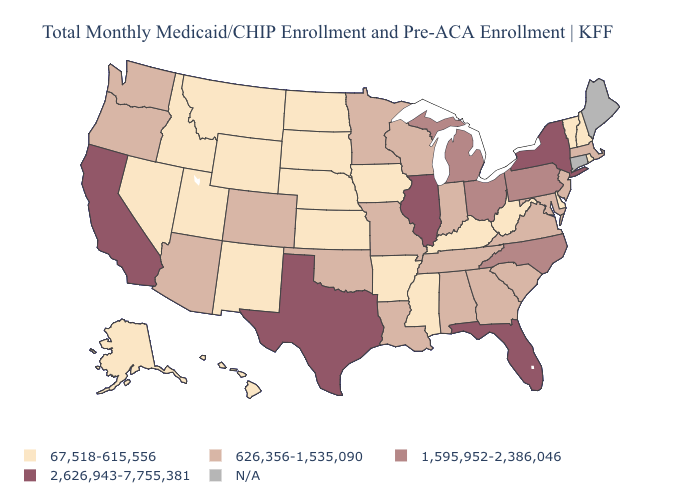Does the first symbol in the legend represent the smallest category?
Be succinct. Yes. What is the lowest value in the West?
Short answer required. 67,518-615,556. What is the highest value in states that border Missouri?
Answer briefly. 2,626,943-7,755,381. What is the value of Maine?
Short answer required. N/A. Name the states that have a value in the range 2,626,943-7,755,381?
Give a very brief answer. California, Florida, Illinois, New York, Texas. Does Florida have the highest value in the South?
Concise answer only. Yes. How many symbols are there in the legend?
Write a very short answer. 5. Name the states that have a value in the range 626,356-1,535,090?
Quick response, please. Alabama, Arizona, Colorado, Georgia, Indiana, Louisiana, Maryland, Massachusetts, Minnesota, Missouri, New Jersey, Oklahoma, Oregon, South Carolina, Tennessee, Virginia, Washington, Wisconsin. What is the value of New Mexico?
Answer briefly. 67,518-615,556. What is the value of New Jersey?
Keep it brief. 626,356-1,535,090. What is the value of Oregon?
Quick response, please. 626,356-1,535,090. Name the states that have a value in the range 1,595,952-2,386,046?
Concise answer only. Michigan, North Carolina, Ohio, Pennsylvania. Name the states that have a value in the range 67,518-615,556?
Concise answer only. Alaska, Arkansas, Delaware, Hawaii, Idaho, Iowa, Kansas, Kentucky, Mississippi, Montana, Nebraska, Nevada, New Hampshire, New Mexico, North Dakota, Rhode Island, South Dakota, Utah, Vermont, West Virginia, Wyoming. 